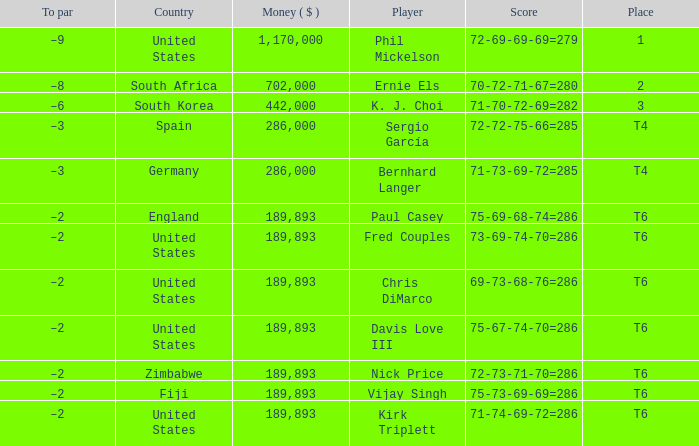What is the Money ($) when the Place is t6, and Player is chris dimarco? 189893.0. 